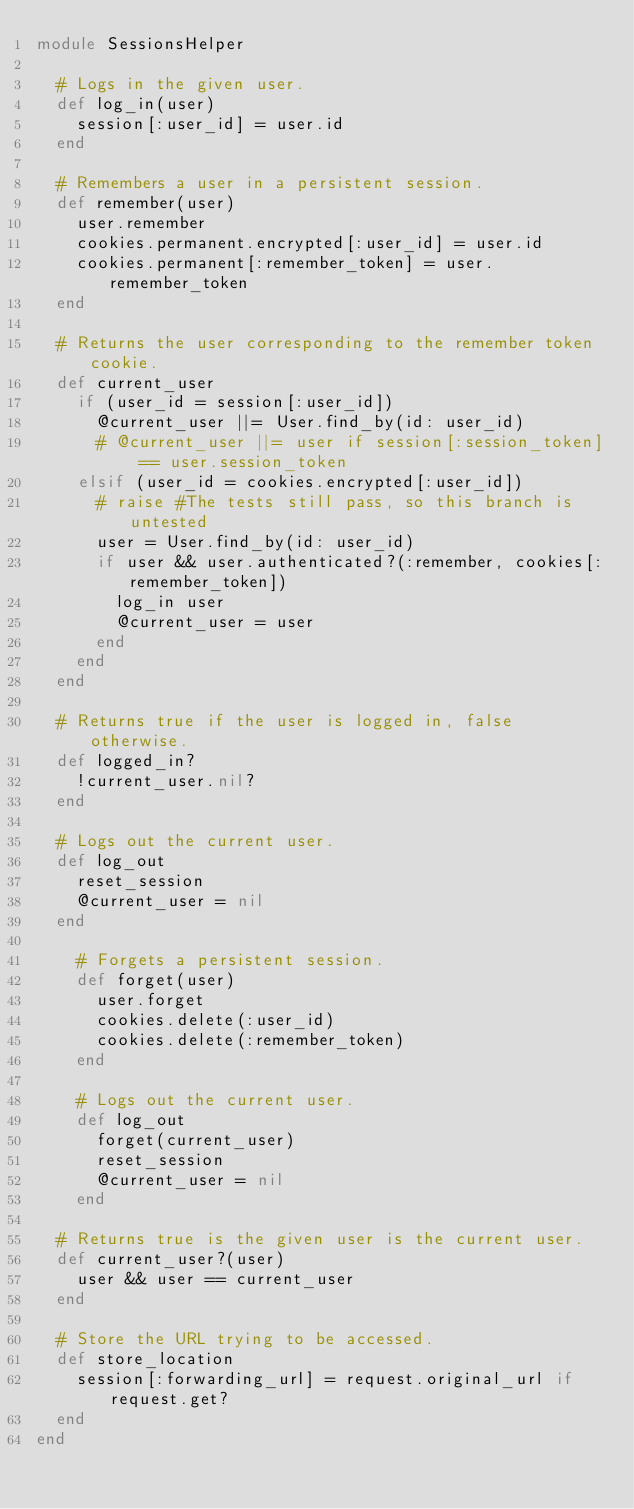Convert code to text. <code><loc_0><loc_0><loc_500><loc_500><_Ruby_>module SessionsHelper

  # Logs in the given user.
  def log_in(user)
    session[:user_id] = user.id
  end

  # Remembers a user in a persistent session.
  def remember(user)
    user.remember
    cookies.permanent.encrypted[:user_id] = user.id
    cookies.permanent[:remember_token] = user.remember_token
  end

  # Returns the user corresponding to the remember token cookie.
  def current_user
    if (user_id = session[:user_id])
      @current_user ||= User.find_by(id: user_id)
      # @current_user ||= user if session[:session_token] == user.session_token
    elsif (user_id = cookies.encrypted[:user_id])
      # raise #The tests still pass, so this branch is untested
      user = User.find_by(id: user_id)
      if user && user.authenticated?(:remember, cookies[:remember_token])
        log_in user
        @current_user = user
      end
    end
  end

  # Returns true if the user is logged in, false otherwise.
  def logged_in?
    !current_user.nil?
  end

  # Logs out the current user.
  def log_out
    reset_session
    @current_user = nil
  end

    # Forgets a persistent session.
    def forget(user)
      user.forget
      cookies.delete(:user_id)
      cookies.delete(:remember_token)
    end
  
    # Logs out the current user.
    def log_out
      forget(current_user)
      reset_session
      @current_user = nil
    end

  # Returns true is the given user is the current user.
  def current_user?(user)
    user && user == current_user
  end

  # Store the URL trying to be accessed.
  def store_location
    session[:forwarding_url] = request.original_url if request.get?
  end
end</code> 